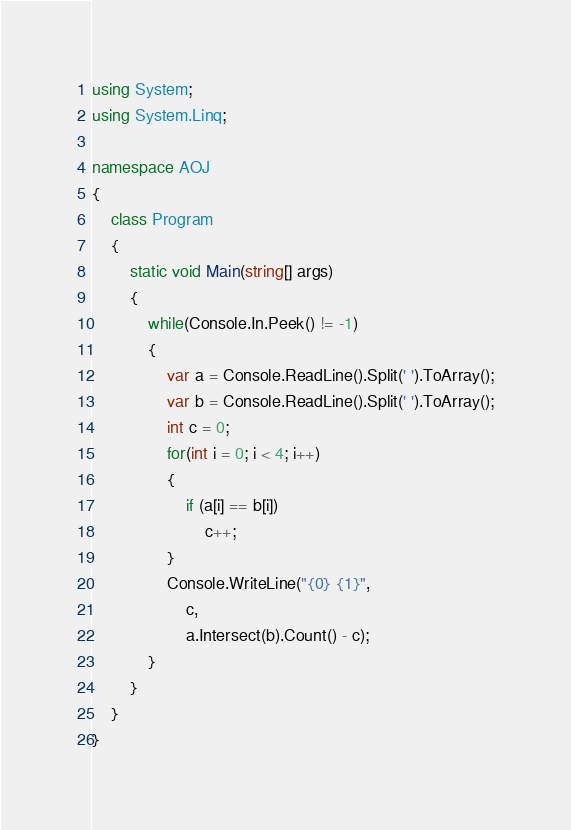Convert code to text. <code><loc_0><loc_0><loc_500><loc_500><_C#_>using System;
using System.Linq;

namespace AOJ
{
    class Program
    {
        static void Main(string[] args)
        {
            while(Console.In.Peek() != -1)
            {
                var a = Console.ReadLine().Split(' ').ToArray();
                var b = Console.ReadLine().Split(' ').ToArray();
                int c = 0;
                for(int i = 0; i < 4; i++)
                {
                    if (a[i] == b[i])
                        c++;
                }
                Console.WriteLine("{0} {1}",
                    c,
                    a.Intersect(b).Count() - c);
            }
        }
    }
}</code> 